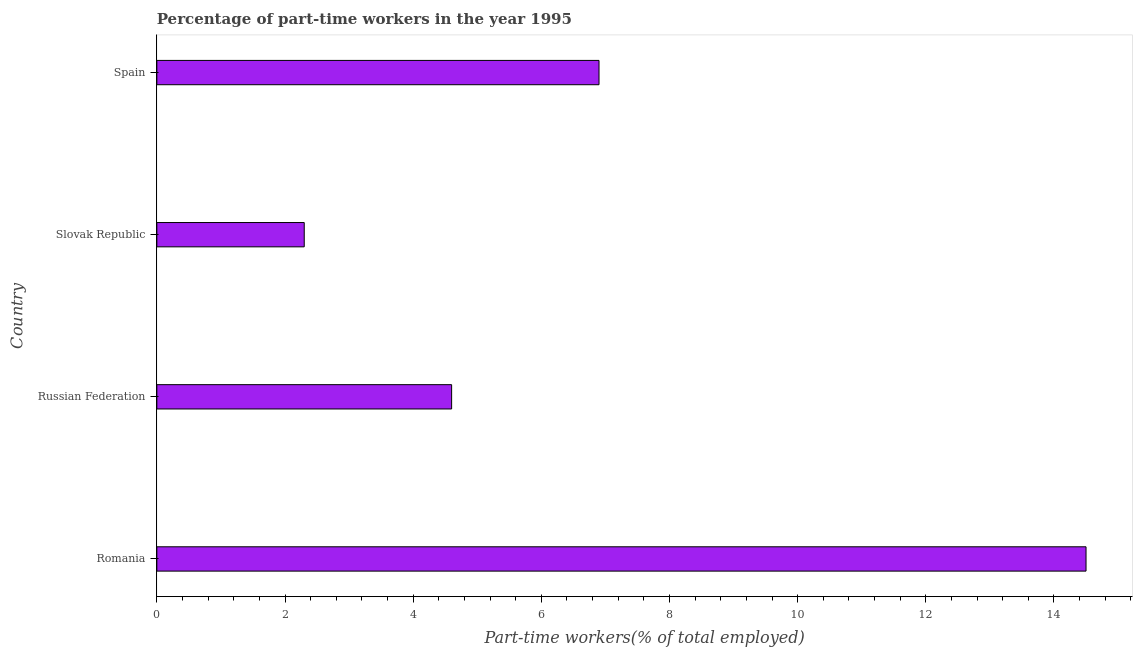Does the graph contain any zero values?
Offer a terse response. No. What is the title of the graph?
Offer a terse response. Percentage of part-time workers in the year 1995. What is the label or title of the X-axis?
Provide a short and direct response. Part-time workers(% of total employed). Across all countries, what is the minimum percentage of part-time workers?
Your response must be concise. 2.3. In which country was the percentage of part-time workers maximum?
Offer a very short reply. Romania. In which country was the percentage of part-time workers minimum?
Make the answer very short. Slovak Republic. What is the sum of the percentage of part-time workers?
Keep it short and to the point. 28.3. What is the average percentage of part-time workers per country?
Keep it short and to the point. 7.08. What is the median percentage of part-time workers?
Keep it short and to the point. 5.75. Is the percentage of part-time workers in Russian Federation less than that in Slovak Republic?
Your answer should be very brief. No. Is the difference between the percentage of part-time workers in Russian Federation and Slovak Republic greater than the difference between any two countries?
Make the answer very short. No. What is the difference between the highest and the second highest percentage of part-time workers?
Ensure brevity in your answer.  7.6. What is the difference between the highest and the lowest percentage of part-time workers?
Your answer should be very brief. 12.2. In how many countries, is the percentage of part-time workers greater than the average percentage of part-time workers taken over all countries?
Your answer should be compact. 1. How many bars are there?
Your answer should be compact. 4. Are all the bars in the graph horizontal?
Ensure brevity in your answer.  Yes. Are the values on the major ticks of X-axis written in scientific E-notation?
Your answer should be very brief. No. What is the Part-time workers(% of total employed) in Romania?
Your answer should be compact. 14.5. What is the Part-time workers(% of total employed) of Russian Federation?
Make the answer very short. 4.6. What is the Part-time workers(% of total employed) in Slovak Republic?
Your response must be concise. 2.3. What is the Part-time workers(% of total employed) of Spain?
Keep it short and to the point. 6.9. What is the difference between the Part-time workers(% of total employed) in Romania and Russian Federation?
Provide a short and direct response. 9.9. What is the difference between the Part-time workers(% of total employed) in Russian Federation and Slovak Republic?
Keep it short and to the point. 2.3. What is the difference between the Part-time workers(% of total employed) in Slovak Republic and Spain?
Provide a short and direct response. -4.6. What is the ratio of the Part-time workers(% of total employed) in Romania to that in Russian Federation?
Offer a terse response. 3.15. What is the ratio of the Part-time workers(% of total employed) in Romania to that in Slovak Republic?
Keep it short and to the point. 6.3. What is the ratio of the Part-time workers(% of total employed) in Romania to that in Spain?
Provide a succinct answer. 2.1. What is the ratio of the Part-time workers(% of total employed) in Russian Federation to that in Slovak Republic?
Provide a short and direct response. 2. What is the ratio of the Part-time workers(% of total employed) in Russian Federation to that in Spain?
Provide a short and direct response. 0.67. What is the ratio of the Part-time workers(% of total employed) in Slovak Republic to that in Spain?
Your response must be concise. 0.33. 